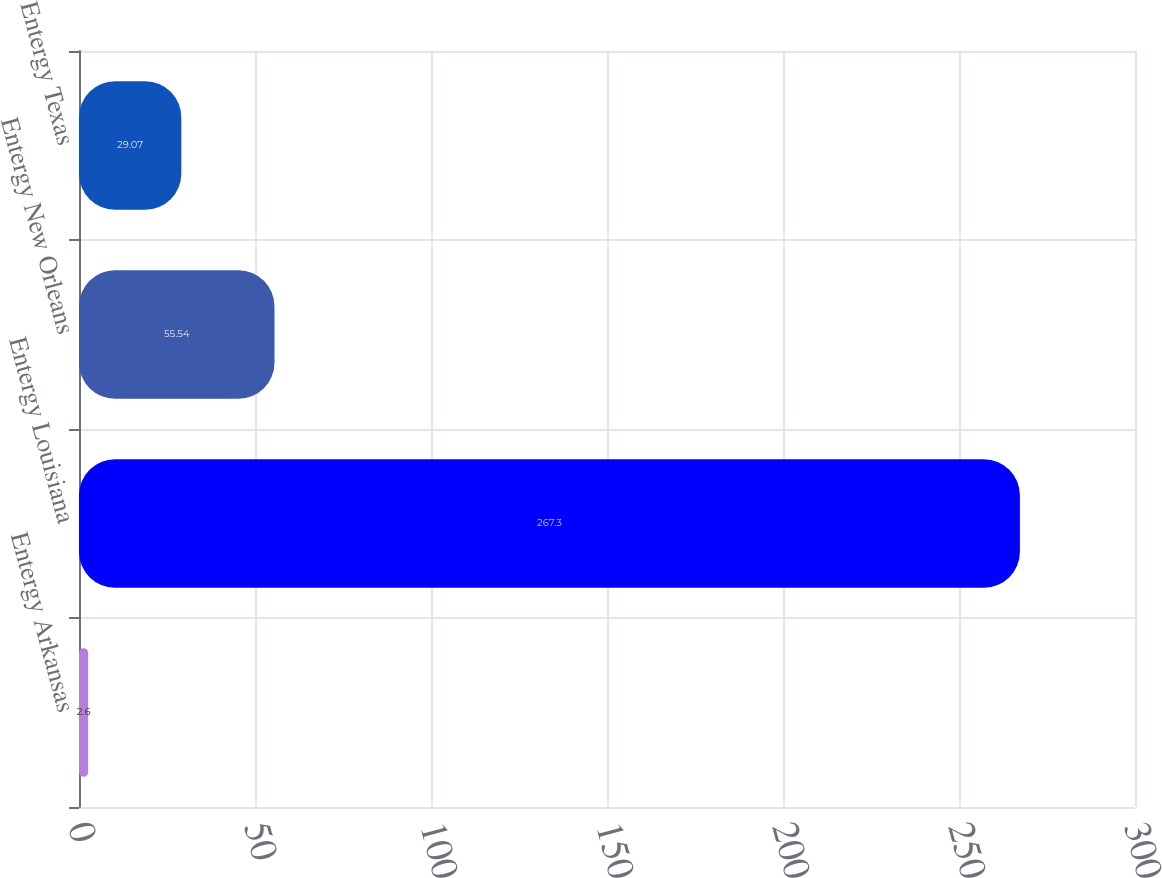Convert chart to OTSL. <chart><loc_0><loc_0><loc_500><loc_500><bar_chart><fcel>Entergy Arkansas<fcel>Entergy Louisiana<fcel>Entergy New Orleans<fcel>Entergy Texas<nl><fcel>2.6<fcel>267.3<fcel>55.54<fcel>29.07<nl></chart> 